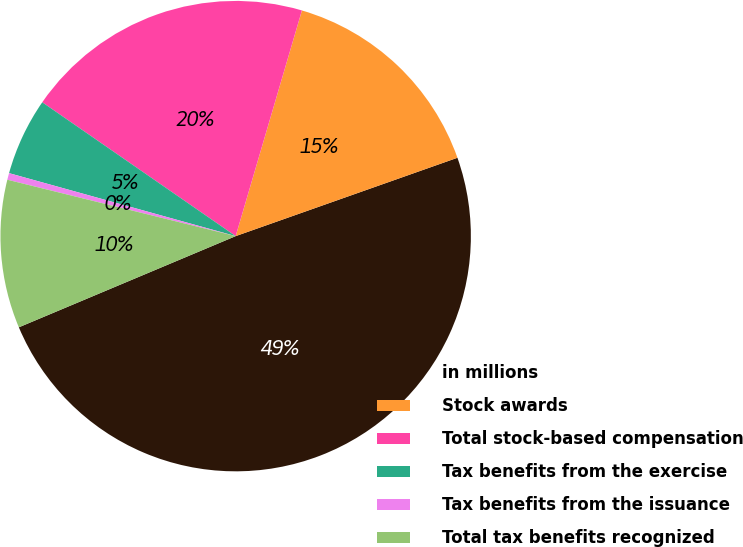Convert chart to OTSL. <chart><loc_0><loc_0><loc_500><loc_500><pie_chart><fcel>in millions<fcel>Stock awards<fcel>Total stock-based compensation<fcel>Tax benefits from the exercise<fcel>Tax benefits from the issuance<fcel>Total tax benefits recognized<nl><fcel>49.07%<fcel>15.05%<fcel>19.91%<fcel>5.32%<fcel>0.46%<fcel>10.19%<nl></chart> 